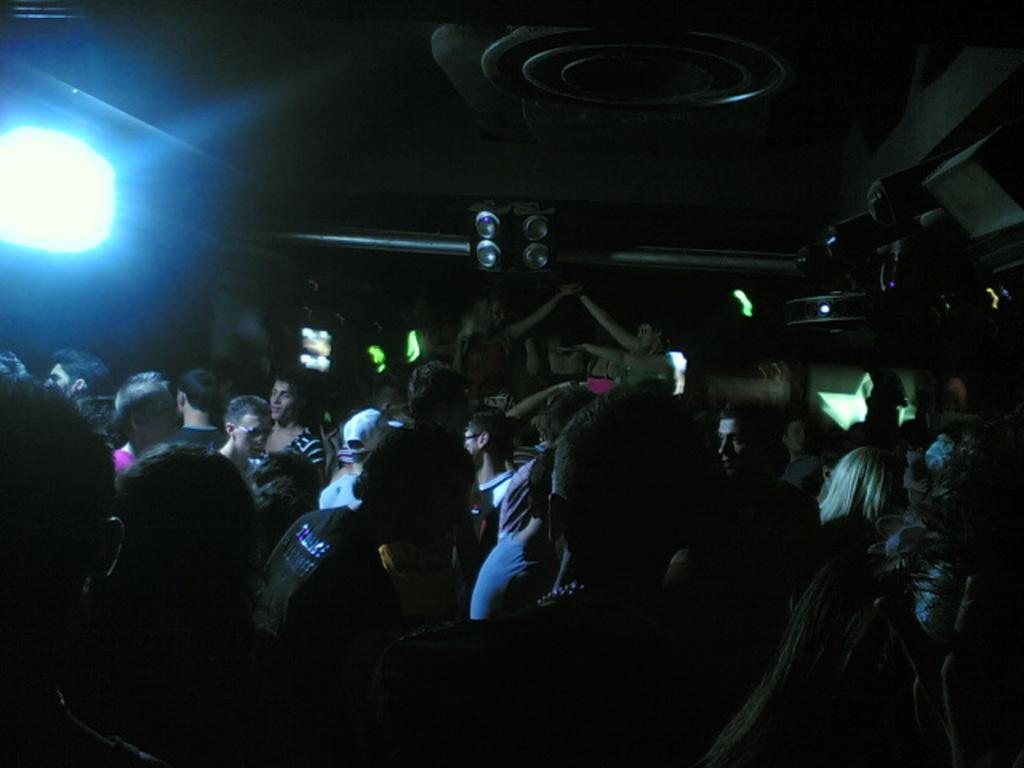How would you summarize this image in a sentence or two? Here we can see a crowd. Top of the image there are speakers and focusing light. 